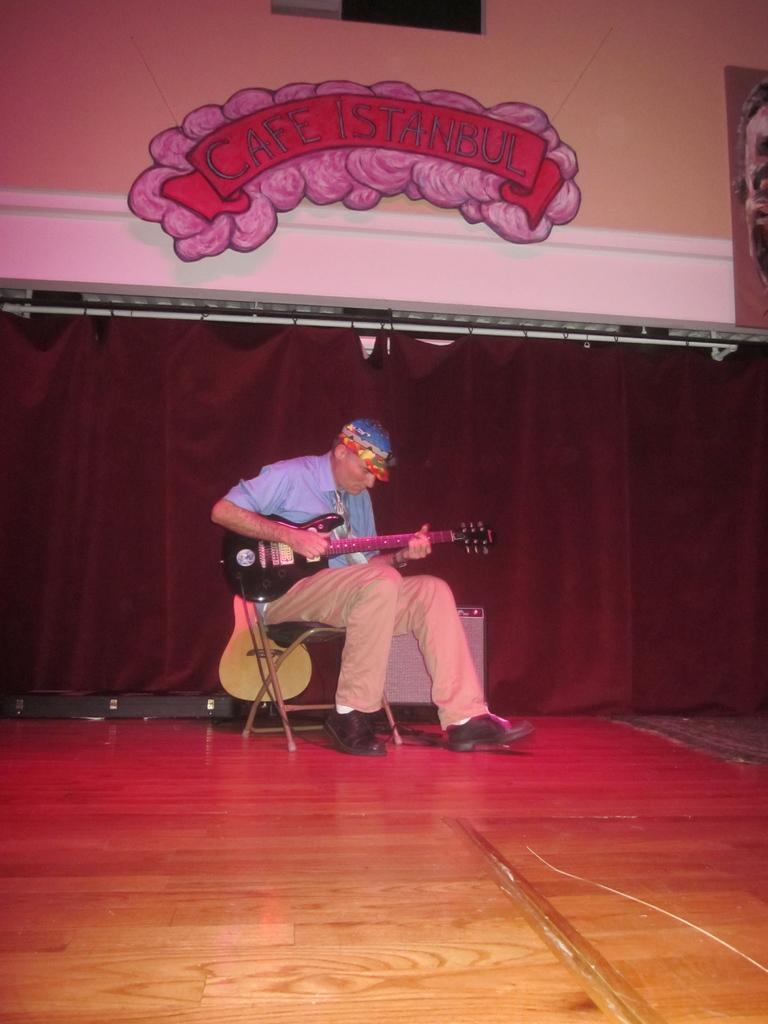Who is present in the image? There is a man in the image. What is the man doing in the image? The man is sitting on a chair and holding a guitar. Are there any other guitars visible in the image? Yes, there is another guitar visible behind the man. What can be seen on the wall in the image? There are boards on the wall. What type of covering is present in the image? There is a curtain in the image. What type of engine can be seen in the image? There is no engine present in the image. How does the man use the time in the image? The image does not provide information about the man using time; it only shows him sitting on a chair and holding a guitar. 